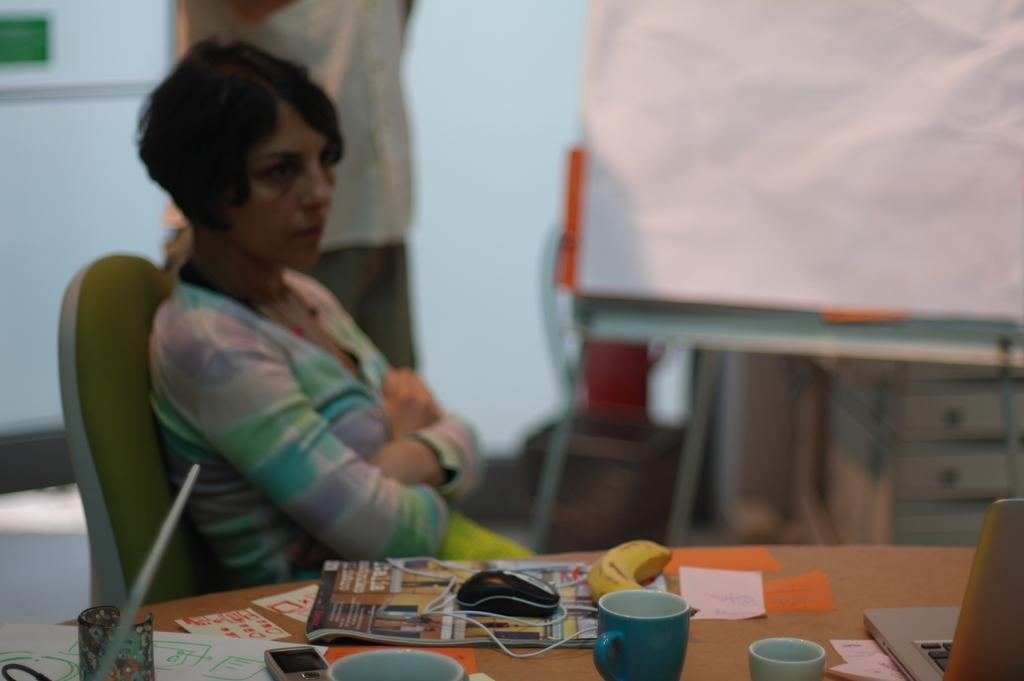What is the person in the image doing? The person is sitting on a chair. What object can be seen next to the person? There is a table in the image. What food item is on the table? There is a banana on the table. What other object is on the table? There is a mouse and a glass on the table. What type of request can be seen on the table in the image? There is no request present in the image; it only shows a person sitting on a chair, a table, a banana, a mouse, and a glass. 